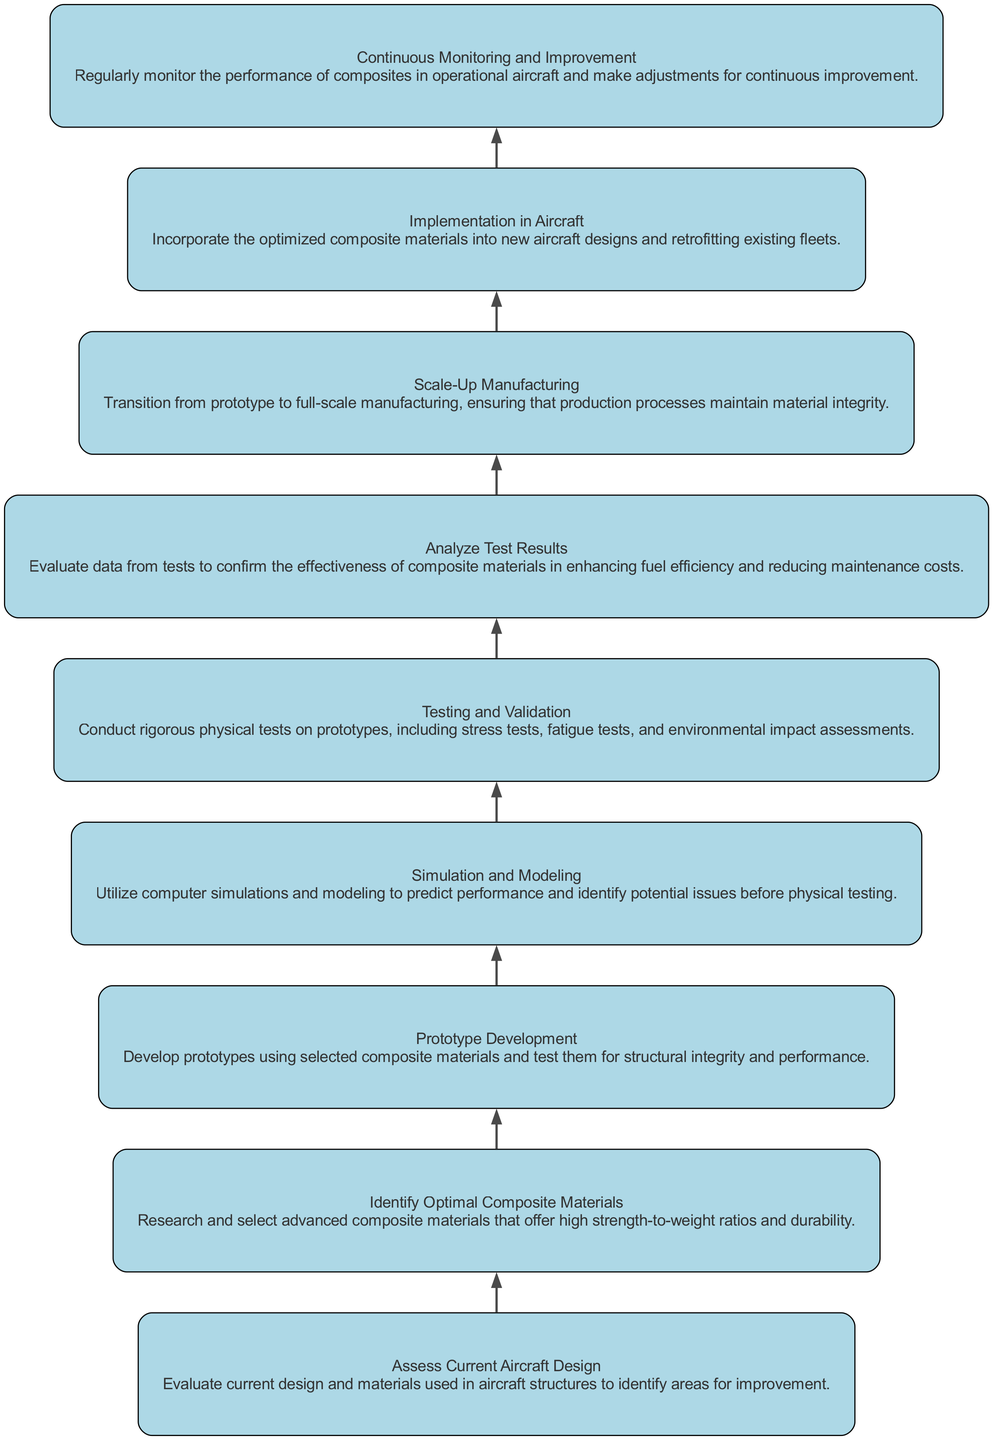What is the first step in the diagram? The first step is to "Assess Current Aircraft Design," which is listed at the bottom of the flowchart.
Answer: Assess Current Aircraft Design How many steps are included in the process? There are a total of nine steps, as each of the elements listed in the diagram corresponds to one step.
Answer: Nine What is the main focus of the "Testing and Validation" step? The "Testing and Validation" step focuses on conducting rigorous physical tests on prototypes, as described in that section of the diagram.
Answer: Conduct rigorous physical tests What comes after "Analyze Test Results"? The step that follows "Analyze Test Results" is "Scale-Up Manufacturing," which indicates the process of transitioning from prototyping to full production.
Answer: Scale-Up Manufacturing Which step involves the use of computer simulations? The "Simulation and Modeling" step involves using computer simulations and modeling to predict performance and identify potential issues.
Answer: Simulation and Modeling What is the ultimate goal after "Implementation in Aircraft"? The goal after "Implementation in Aircraft" is "Continuous Monitoring and Improvement," indicating an ongoing process of performance evaluation.
Answer: Continuous Monitoring and Improvement Which two steps are directly linked before "Prototype Development"? The two steps directly linked before "Prototype Development" are "Identify Optimal Composite Materials" and "Assess Current Aircraft Design," indicating their sequential relationship.
Answer: Identify Optimal Composite Materials and Assess Current Aircraft Design How does "Testing and Validation" contribute to fuel efficiency? "Testing and Validation" validates the effectiveness of composite materials, which ultimately contributes to enhancing fuel efficiency and reducing maintenance costs.
Answer: Validates effectiveness of composite materials What kind of materials are selected in the second step? The second step involves selecting advanced composite materials that offer high strength-to-weight ratios and durability.
Answer: Advanced composite materials 